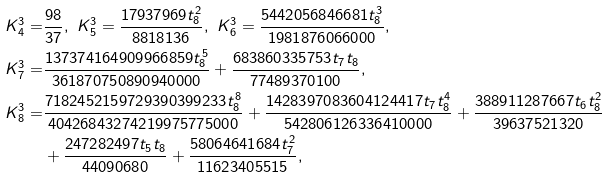<formula> <loc_0><loc_0><loc_500><loc_500>K _ { 4 } ^ { 3 } = & \frac { 9 8 } { 3 7 } , \ K _ { 5 } ^ { 3 } = \frac { 1 7 9 3 7 9 6 9 t _ { 8 } ^ { 2 } } { 8 8 1 8 1 3 6 } , \ K _ { 6 } ^ { 3 } = \frac { 5 4 4 2 0 5 6 8 4 6 6 8 1 t _ { 8 } ^ { 3 } } { 1 9 8 1 8 7 6 0 6 6 0 0 0 } , \\ K _ { 7 } ^ { 3 } = & \frac { 1 3 7 3 7 4 1 6 4 9 0 9 9 6 6 8 5 9 t _ { 8 } ^ { 5 } } { 3 6 1 8 7 0 7 5 0 8 9 0 9 4 0 0 0 0 } + \frac { 6 8 3 8 6 0 3 3 5 7 5 3 t _ { 7 } t _ { 8 } } { 7 7 4 8 9 3 7 0 1 0 0 } , \\ K _ { 8 } ^ { 3 } = & \frac { 7 1 8 2 4 5 2 1 5 9 7 2 9 3 9 0 3 9 9 2 3 3 t _ { 8 } ^ { 8 } } { 4 0 4 2 6 8 4 3 2 7 4 2 1 9 9 7 5 7 7 5 0 0 0 } + \frac { 1 4 2 8 3 9 7 0 8 3 6 0 4 1 2 4 4 1 7 t _ { 7 } t _ { 8 } ^ { 4 } } { 5 4 2 8 0 6 1 2 6 3 3 6 4 1 0 0 0 0 } + \frac { 3 8 8 9 1 1 2 8 7 6 6 7 t _ { 6 } t _ { 8 } ^ { 2 } } { 3 9 6 3 7 5 2 1 3 2 0 } \\ & + \frac { 2 4 7 2 8 2 4 9 7 t _ { 5 } t _ { 8 } } { 4 4 0 9 0 6 8 0 } + \frac { 5 8 0 6 4 6 4 1 6 8 4 t _ { 7 } ^ { 2 } } { 1 1 6 2 3 4 0 5 5 1 5 } ,</formula> 